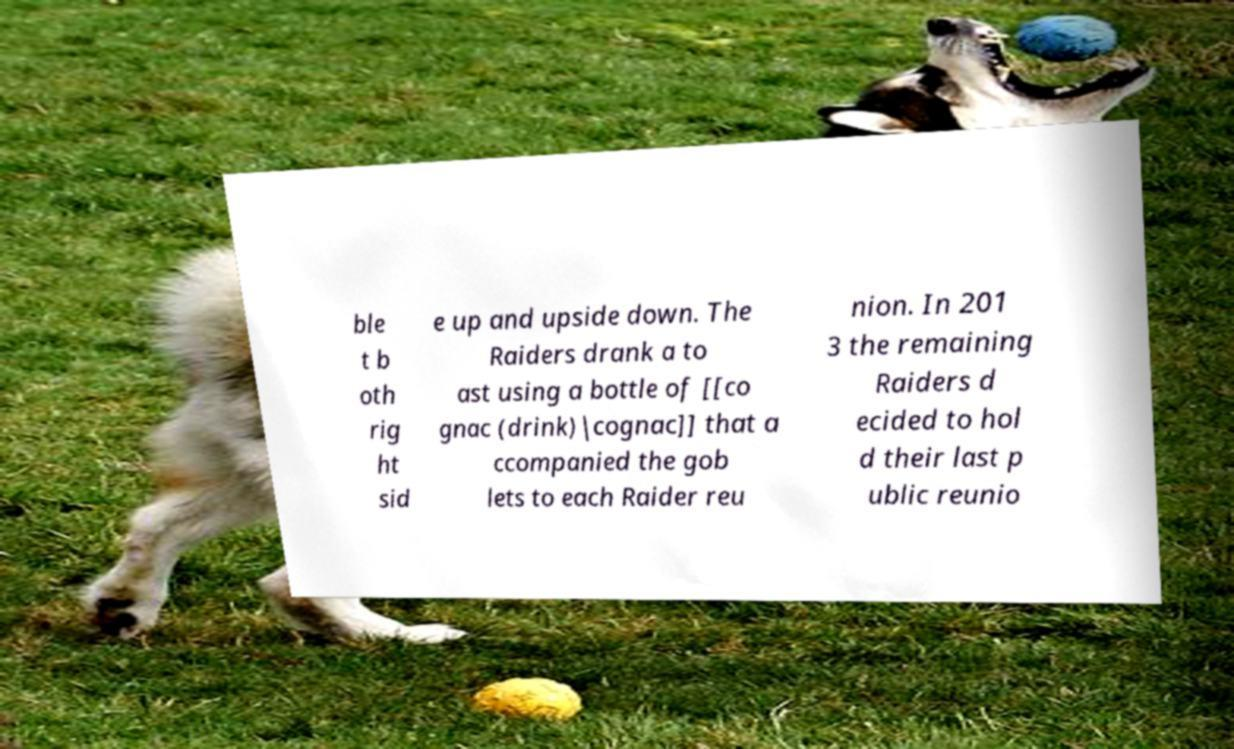Please identify and transcribe the text found in this image. ble t b oth rig ht sid e up and upside down. The Raiders drank a to ast using a bottle of [[co gnac (drink)|cognac]] that a ccompanied the gob lets to each Raider reu nion. In 201 3 the remaining Raiders d ecided to hol d their last p ublic reunio 